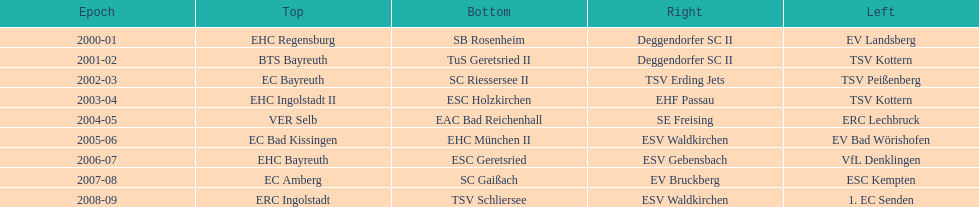Can you give me this table as a dict? {'header': ['Epoch', 'Top', 'Bottom', 'Right', 'Left'], 'rows': [['2000-01', 'EHC Regensburg', 'SB Rosenheim', 'Deggendorfer SC II', 'EV Landsberg'], ['2001-02', 'BTS Bayreuth', 'TuS Geretsried II', 'Deggendorfer SC II', 'TSV Kottern'], ['2002-03', 'EC Bayreuth', 'SC Riessersee II', 'TSV Erding Jets', 'TSV Peißenberg'], ['2003-04', 'EHC Ingolstadt II', 'ESC Holzkirchen', 'EHF Passau', 'TSV Kottern'], ['2004-05', 'VER Selb', 'EAC Bad Reichenhall', 'SE Freising', 'ERC Lechbruck'], ['2005-06', 'EC Bad Kissingen', 'EHC München II', 'ESV Waldkirchen', 'EV Bad Wörishofen'], ['2006-07', 'EHC Bayreuth', 'ESC Geretsried', 'ESV Gebensbach', 'VfL Denklingen'], ['2007-08', 'EC Amberg', 'SC Gaißach', 'EV Bruckberg', 'ESC Kempten'], ['2008-09', 'ERC Ingolstadt', 'TSV Schliersee', 'ESV Waldkirchen', '1. EC Senden']]} Starting with the 2007 - 08 season, does ecs kempten appear in any of the previous years? No. 